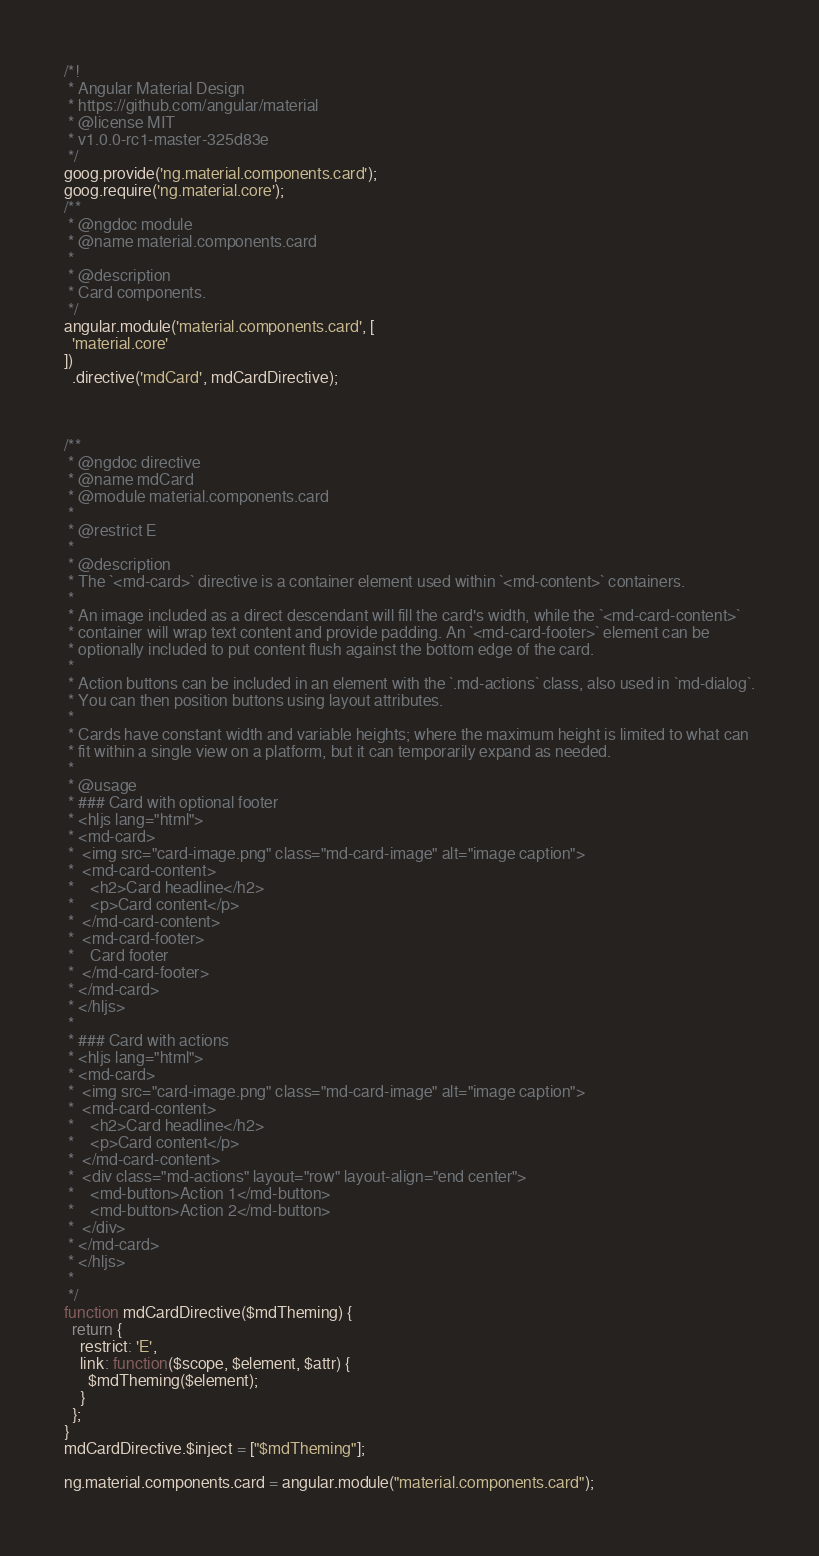Convert code to text. <code><loc_0><loc_0><loc_500><loc_500><_JavaScript_>/*!
 * Angular Material Design
 * https://github.com/angular/material
 * @license MIT
 * v1.0.0-rc1-master-325d83e
 */
goog.provide('ng.material.components.card');
goog.require('ng.material.core');
/**
 * @ngdoc module
 * @name material.components.card
 *
 * @description
 * Card components.
 */
angular.module('material.components.card', [
  'material.core'
])
  .directive('mdCard', mdCardDirective);



/**
 * @ngdoc directive
 * @name mdCard
 * @module material.components.card
 *
 * @restrict E
 *
 * @description
 * The `<md-card>` directive is a container element used within `<md-content>` containers.
 *
 * An image included as a direct descendant will fill the card's width, while the `<md-card-content>`
 * container will wrap text content and provide padding. An `<md-card-footer>` element can be
 * optionally included to put content flush against the bottom edge of the card.
 *
 * Action buttons can be included in an element with the `.md-actions` class, also used in `md-dialog`.
 * You can then position buttons using layout attributes.
 *
 * Cards have constant width and variable heights; where the maximum height is limited to what can
 * fit within a single view on a platform, but it can temporarily expand as needed.
 *
 * @usage
 * ### Card with optional footer
 * <hljs lang="html">
 * <md-card>
 *  <img src="card-image.png" class="md-card-image" alt="image caption">
 *  <md-card-content>
 *    <h2>Card headline</h2>
 *    <p>Card content</p>
 *  </md-card-content>
 *  <md-card-footer>
 *    Card footer
 *  </md-card-footer>
 * </md-card>
 * </hljs>
 *
 * ### Card with actions
 * <hljs lang="html">
 * <md-card>
 *  <img src="card-image.png" class="md-card-image" alt="image caption">
 *  <md-card-content>
 *    <h2>Card headline</h2>
 *    <p>Card content</p>
 *  </md-card-content>
 *  <div class="md-actions" layout="row" layout-align="end center">
 *    <md-button>Action 1</md-button>
 *    <md-button>Action 2</md-button>
 *  </div>
 * </md-card>
 * </hljs>
 *
 */
function mdCardDirective($mdTheming) {
  return {
    restrict: 'E',
    link: function($scope, $element, $attr) {
      $mdTheming($element);
    }
  };
}
mdCardDirective.$inject = ["$mdTheming"];

ng.material.components.card = angular.module("material.components.card");</code> 